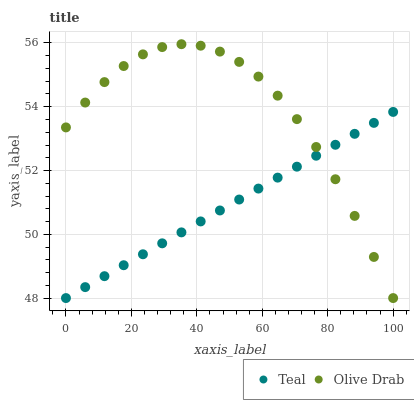Does Teal have the minimum area under the curve?
Answer yes or no. Yes. Does Olive Drab have the maximum area under the curve?
Answer yes or no. Yes. Does Teal have the maximum area under the curve?
Answer yes or no. No. Is Teal the smoothest?
Answer yes or no. Yes. Is Olive Drab the roughest?
Answer yes or no. Yes. Is Teal the roughest?
Answer yes or no. No. Does Olive Drab have the lowest value?
Answer yes or no. Yes. Does Olive Drab have the highest value?
Answer yes or no. Yes. Does Teal have the highest value?
Answer yes or no. No. Does Teal intersect Olive Drab?
Answer yes or no. Yes. Is Teal less than Olive Drab?
Answer yes or no. No. Is Teal greater than Olive Drab?
Answer yes or no. No. 